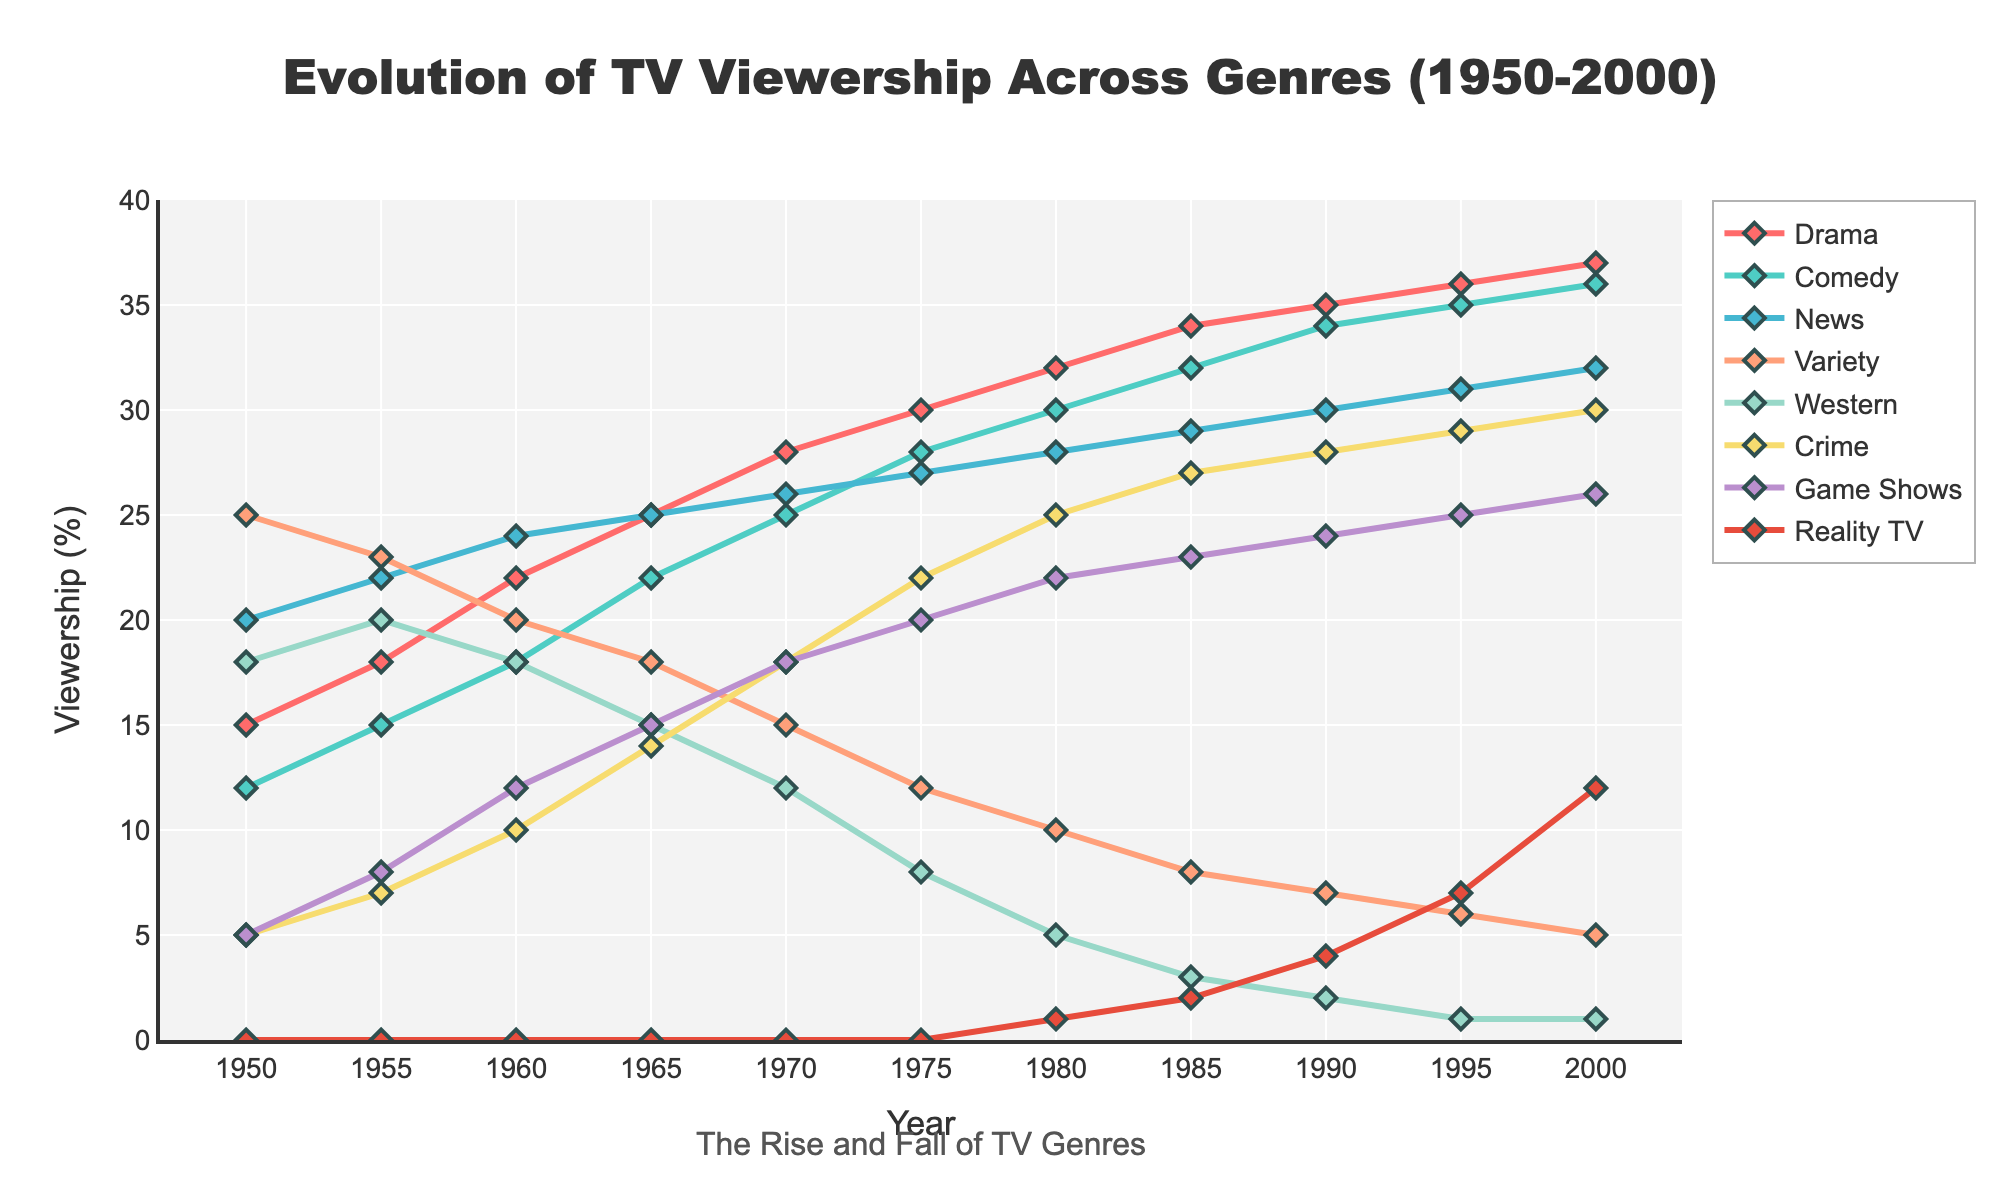What genre had the highest viewership in 1970? To find the answer, locate the 1970 point on the x-axis. Then, check the y-values for each genre. The Drama genre has a viewership of 28%, which is the highest.
Answer: Drama How did the viewership for Westerns change from 1950 to 2000? Locate the 1950 and 2000 points on the x-axis. The viewership for Westerns was 18% in 1950 and 1% in 2000. Calculate the difference: 18% - 1% = 17%. Viewership decreased by 17 percentage points.
Answer: Decreased by 17% Which genre showed the most consistent increase in viewership over the period? Observe the trends for each genre from 1950 to 2000. Drama consistently increases from 15% to 37%; no other genre has an uninterrupted upward trend over the entire period.
Answer: Drama Compare viewership trends of Reality TV and Game Shows in the 1990s. Observe the lines for Reality TV and Game Shows from 1990 to 2000. Reality TV increases from 4% to 12%, while Game Shows increase from 24% to 26%. Thus, Reality TV increased more significantly.
Answer: Reality TV increased more significantly In which year was the viewership for Variety shows equal to the viewership for Crime shows? Identify the intersection points of Variety and Crime genre lines. The lines intersect around the year 1980, where both have a viewership of 10%.
Answer: 1980 What was the average viewership of News from 1960 to 1980? Locate the points for News in 1960 (24%), 1965 (25%), 1970 (26%), 1975 (27%), and 1980 (28%). Calculate the average: (24 + 25 + 26 + 27 + 28) / 5 = 26%.
Answer: 26% Which genres experienced a decline in viewership every decade after reaching peak viewership? Look for peaks in lines followed by consistent declines. Variety peaked at 25% in 1950 and declined steadily afterward. Western peaked at 20% in 1955 and declined.
Answer: Variety and Western What is the total viewership for Drama and Comedy in 1990? Add the viewership percentages for Drama (35%) and Comedy (34%) in 1990: 35% + 34% = 69%.
Answer: 69% Which genre had the least change in viewership over the period? Calculate the difference between start and end points for each genre. News had a modest increase from 20% to 32%, a difference of 12 percentage points, which is the lowest change compared to others.
Answer: News 